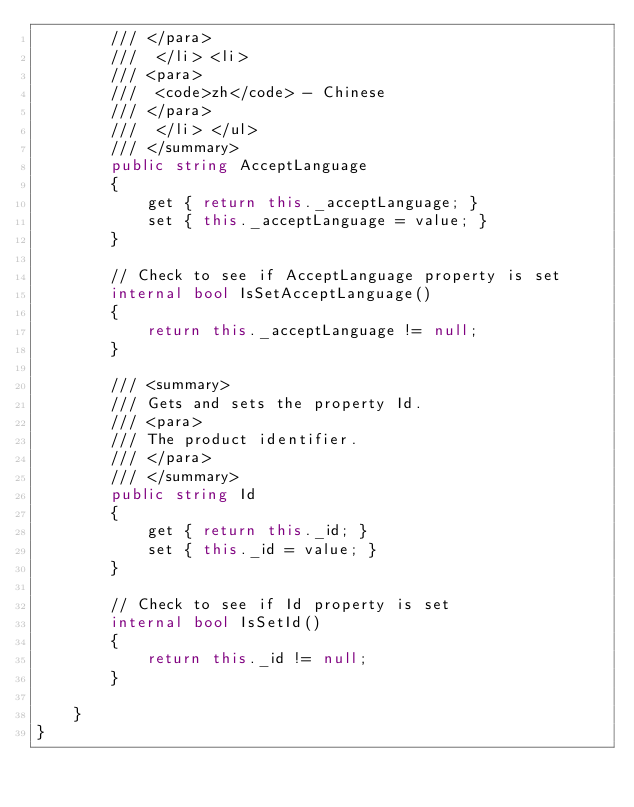Convert code to text. <code><loc_0><loc_0><loc_500><loc_500><_C#_>        /// </para>
        ///  </li> <li> 
        /// <para>
        ///  <code>zh</code> - Chinese
        /// </para>
        ///  </li> </ul>
        /// </summary>
        public string AcceptLanguage
        {
            get { return this._acceptLanguage; }
            set { this._acceptLanguage = value; }
        }

        // Check to see if AcceptLanguage property is set
        internal bool IsSetAcceptLanguage()
        {
            return this._acceptLanguage != null;
        }

        /// <summary>
        /// Gets and sets the property Id. 
        /// <para>
        /// The product identifier.
        /// </para>
        /// </summary>
        public string Id
        {
            get { return this._id; }
            set { this._id = value; }
        }

        // Check to see if Id property is set
        internal bool IsSetId()
        {
            return this._id != null;
        }

    }
}</code> 